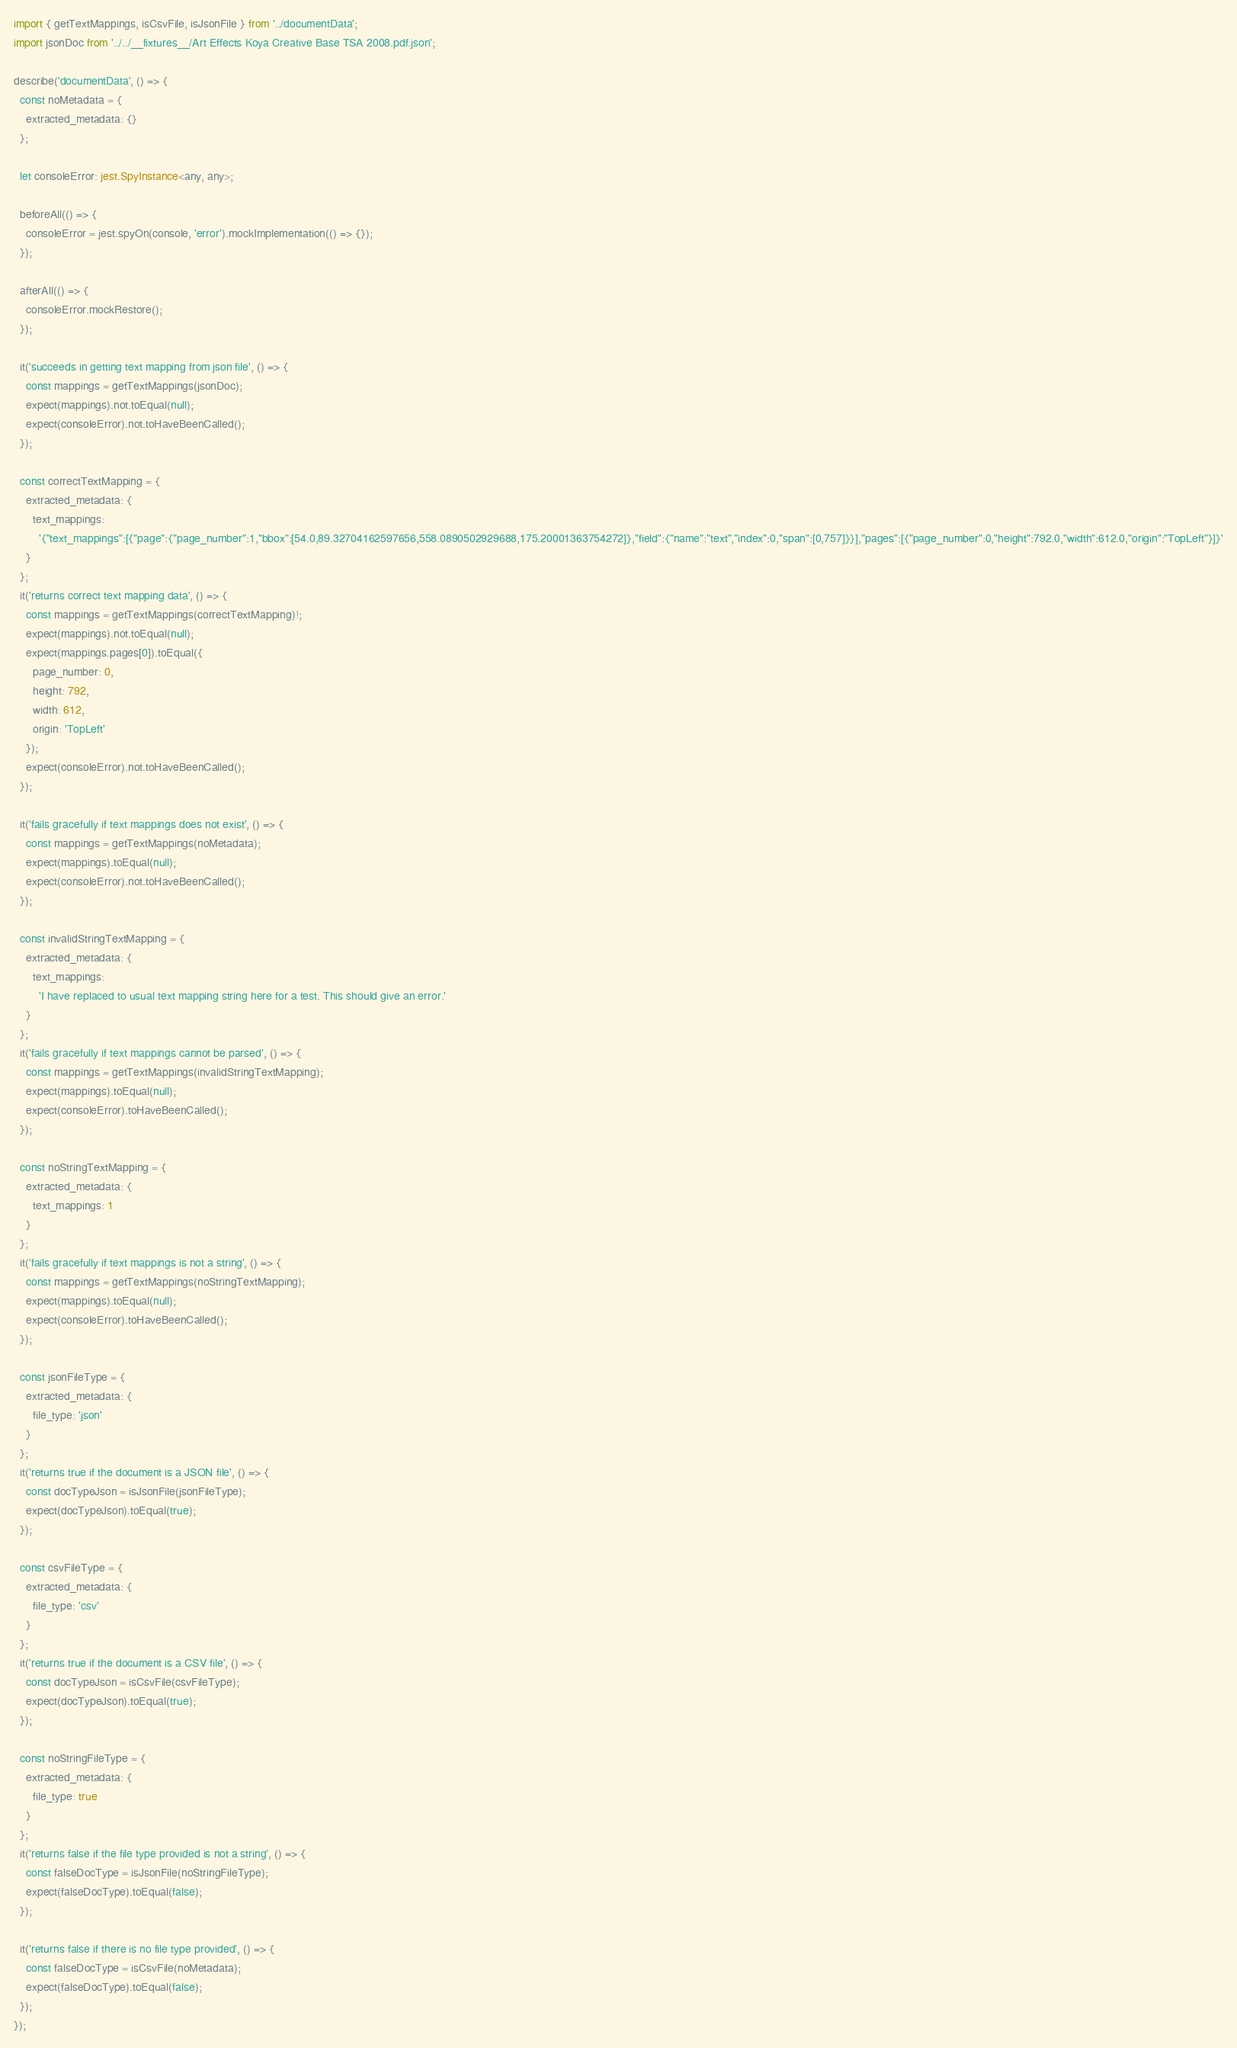Convert code to text. <code><loc_0><loc_0><loc_500><loc_500><_TypeScript_>import { getTextMappings, isCsvFile, isJsonFile } from '../documentData';
import jsonDoc from '../../__fixtures__/Art Effects Koya Creative Base TSA 2008.pdf.json';

describe('documentData', () => {
  const noMetadata = {
    extracted_metadata: {}
  };

  let consoleError: jest.SpyInstance<any, any>;

  beforeAll(() => {
    consoleError = jest.spyOn(console, 'error').mockImplementation(() => {});
  });

  afterAll(() => {
    consoleError.mockRestore();
  });

  it('succeeds in getting text mapping from json file', () => {
    const mappings = getTextMappings(jsonDoc);
    expect(mappings).not.toEqual(null);
    expect(consoleError).not.toHaveBeenCalled();
  });

  const correctTextMapping = {
    extracted_metadata: {
      text_mappings:
        '{"text_mappings":[{"page":{"page_number":1,"bbox":[54.0,89.32704162597656,558.0890502929688,175.20001363754272]},"field":{"name":"text","index":0,"span":[0,757]}}],"pages":[{"page_number":0,"height":792.0,"width":612.0,"origin":"TopLeft"}]}'
    }
  };
  it('returns correct text mapping data', () => {
    const mappings = getTextMappings(correctTextMapping)!;
    expect(mappings).not.toEqual(null);
    expect(mappings.pages[0]).toEqual({
      page_number: 0,
      height: 792,
      width: 612,
      origin: 'TopLeft'
    });
    expect(consoleError).not.toHaveBeenCalled();
  });

  it('fails gracefully if text mappings does not exist', () => {
    const mappings = getTextMappings(noMetadata);
    expect(mappings).toEqual(null);
    expect(consoleError).not.toHaveBeenCalled();
  });

  const invalidStringTextMapping = {
    extracted_metadata: {
      text_mappings:
        'I have replaced to usual text mapping string here for a test. This should give an error.'
    }
  };
  it('fails gracefully if text mappings cannot be parsed', () => {
    const mappings = getTextMappings(invalidStringTextMapping);
    expect(mappings).toEqual(null);
    expect(consoleError).toHaveBeenCalled();
  });

  const noStringTextMapping = {
    extracted_metadata: {
      text_mappings: 1
    }
  };
  it('fails gracefully if text mappings is not a string', () => {
    const mappings = getTextMappings(noStringTextMapping);
    expect(mappings).toEqual(null);
    expect(consoleError).toHaveBeenCalled();
  });

  const jsonFileType = {
    extracted_metadata: {
      file_type: 'json'
    }
  };
  it('returns true if the document is a JSON file', () => {
    const docTypeJson = isJsonFile(jsonFileType);
    expect(docTypeJson).toEqual(true);
  });

  const csvFileType = {
    extracted_metadata: {
      file_type: 'csv'
    }
  };
  it('returns true if the document is a CSV file', () => {
    const docTypeJson = isCsvFile(csvFileType);
    expect(docTypeJson).toEqual(true);
  });

  const noStringFileType = {
    extracted_metadata: {
      file_type: true
    }
  };
  it('returns false if the file type provided is not a string', () => {
    const falseDocType = isJsonFile(noStringFileType);
    expect(falseDocType).toEqual(false);
  });

  it('returns false if there is no file type provided', () => {
    const falseDocType = isCsvFile(noMetadata);
    expect(falseDocType).toEqual(false);
  });
});
</code> 